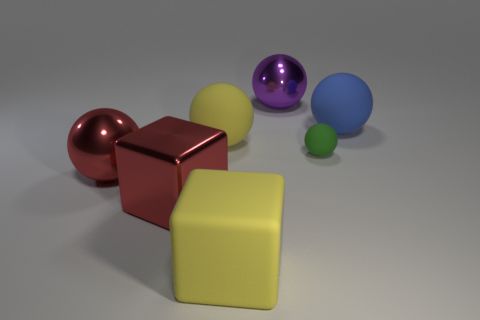Is there a yellow rubber object behind the big block to the right of the big yellow matte ball?
Make the answer very short. Yes. There is a large blue thing that is the same shape as the green object; what is its material?
Offer a terse response. Rubber. How many large blue objects are in front of the matte sphere on the left side of the green object?
Provide a succinct answer. 0. Are there any other things that have the same color as the small thing?
Your answer should be very brief. No. How many objects are either purple rubber cubes or things in front of the big blue sphere?
Your answer should be very brief. 5. There is a yellow thing that is behind the block that is on the right side of the yellow object that is left of the yellow block; what is it made of?
Offer a very short reply. Rubber. What size is the blue thing that is the same material as the large yellow sphere?
Give a very brief answer. Large. What is the color of the rubber thing that is in front of the big red thing that is in front of the big red metal sphere?
Offer a terse response. Yellow. What number of big objects are made of the same material as the blue ball?
Keep it short and to the point. 2. What number of shiny things are either big red spheres or red objects?
Ensure brevity in your answer.  2. 